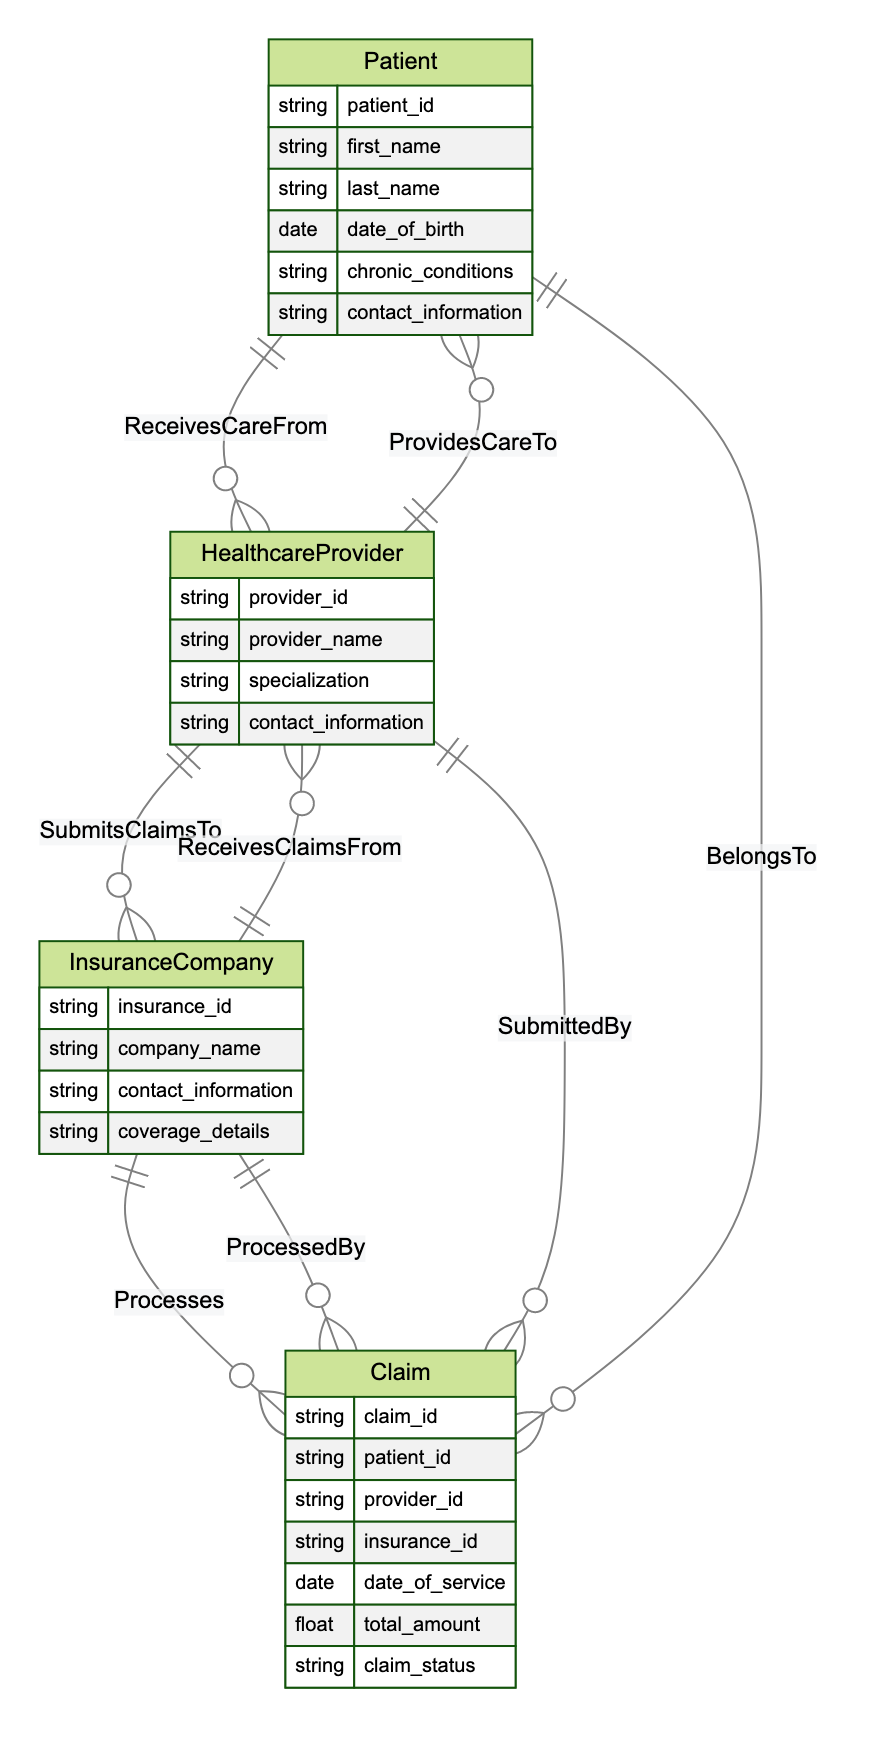What entity submits claims to the insurance company? The relationship diagram indicates that the Healthcare Provider submits claims to the Insurance Company. Specifically, there is a relationship labeled "SubmitsClaimsTo" connecting Healthcare Provider to Insurance Company.
Answer: Healthcare Provider How many attributes does the Claim entity have? The Claim entity has seven attributes listed in the diagram: claim_id, patient_id, provider_id, insurance_id, date_of_service, total_amount, and claim_status. Counting these attributes gives a total of seven.
Answer: Seven What is the relationship between Claim and Patient? According to the diagram, the relationship between Claim and Patient is labeled "BelongsTo," indicating that each claim is associated with one patient.
Answer: BelongsTo Which entity processes the claims? The diagram shows that the Insurance Company is the entity that processes claims, as denoted by the relationship "Processes" between Insurance Company and Claim.
Answer: Insurance Company How many entities are in the diagram? The diagram lists four distinct entities: Patient, Healthcare Provider, Insurance Company, and Claim. Counting these gives a total of four entities.
Answer: Four What type of care does the Healthcare Provider provide to the Patient? From the diagram, it is clear that the Healthcare Provider provides care to the Patient, signified by the relationship labeled "ProvidesCareTo."
Answer: ProvidesCareTo What is the total count of relationships depicted in the diagram? There are a total of eight relationships illustrated in the diagram: ReceivesCareFrom, ProvidesCareTo, SubmitsClaimsTo, ReceivesClaimsFrom, Processes, BelongsTo, SubmittedBy, and ProcessedBy. Thus, counting these pairs gives a total of eight relationships.
Answer: Eight Which entity has the attribute "coverage details"? According to the diagram, the Insurance Company entity possesses the attribute "coverage details," specified among its listed attributes.
Answer: Insurance Company What information does the Patient entity contain regarding chronic conditions? The Patient entity includes an attribute titled "chronic_conditions," which relates to the health profile of the patient and captures information about any ongoing health issues.
Answer: chronic_conditions 